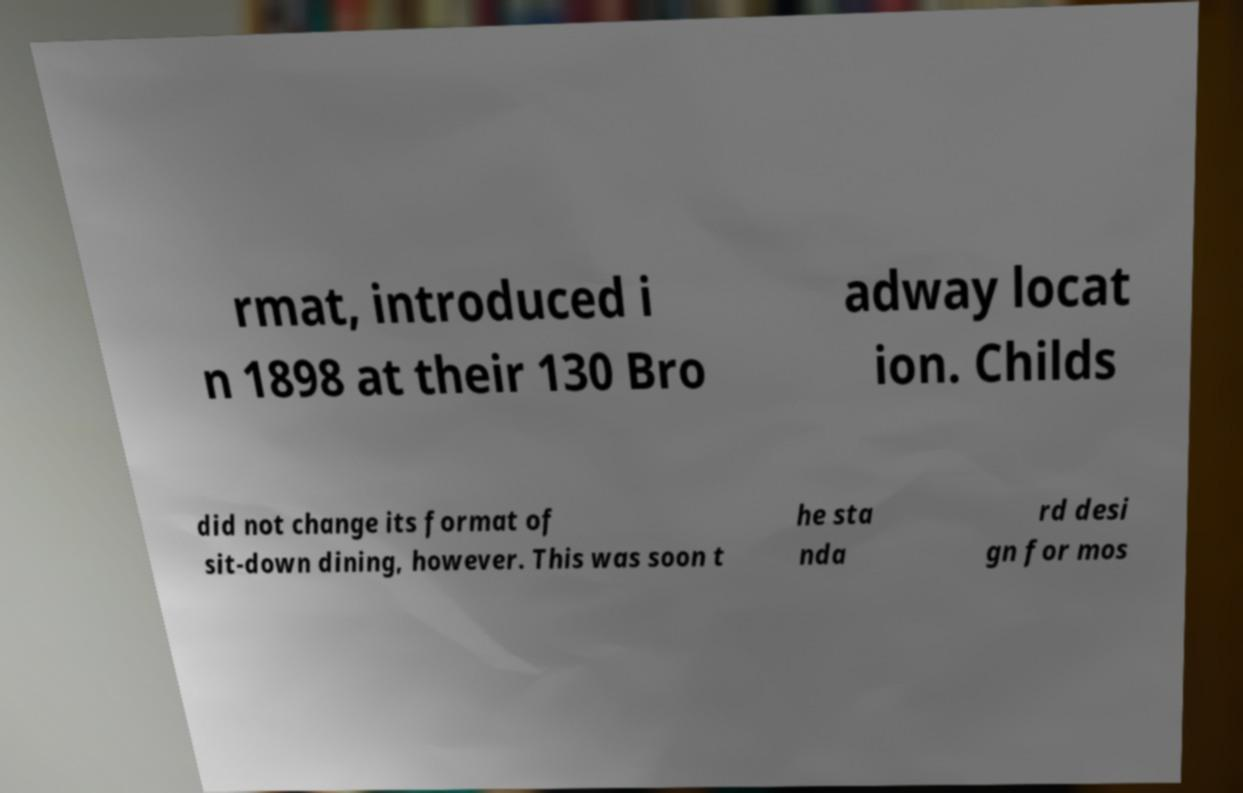Please read and relay the text visible in this image. What does it say? rmat, introduced i n 1898 at their 130 Bro adway locat ion. Childs did not change its format of sit-down dining, however. This was soon t he sta nda rd desi gn for mos 